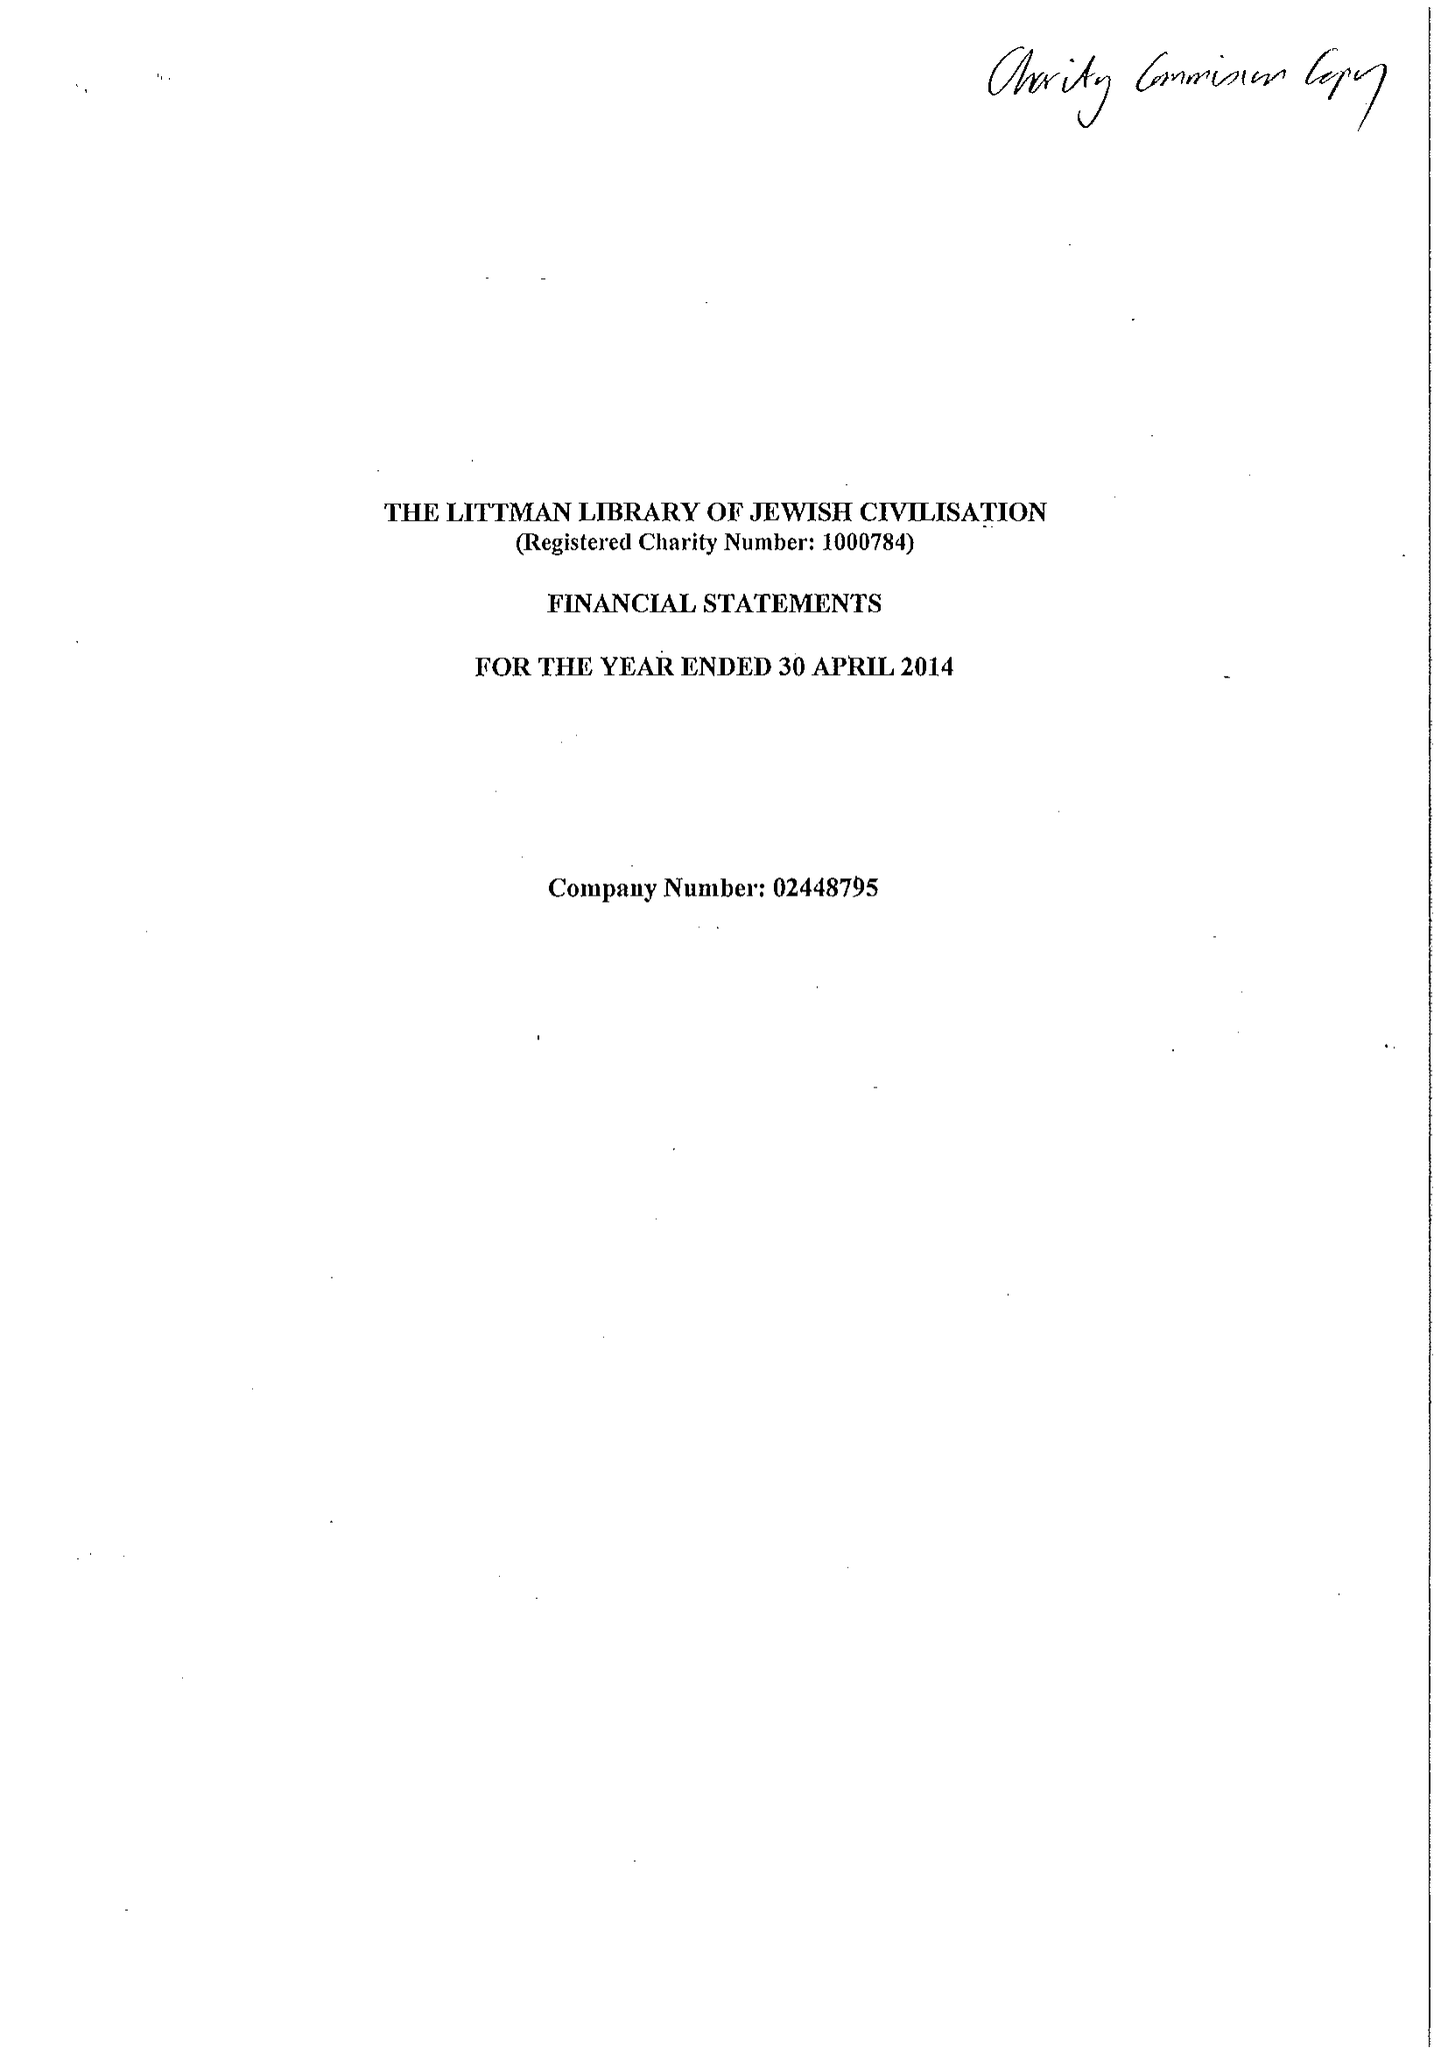What is the value for the charity_number?
Answer the question using a single word or phrase. 1000784 